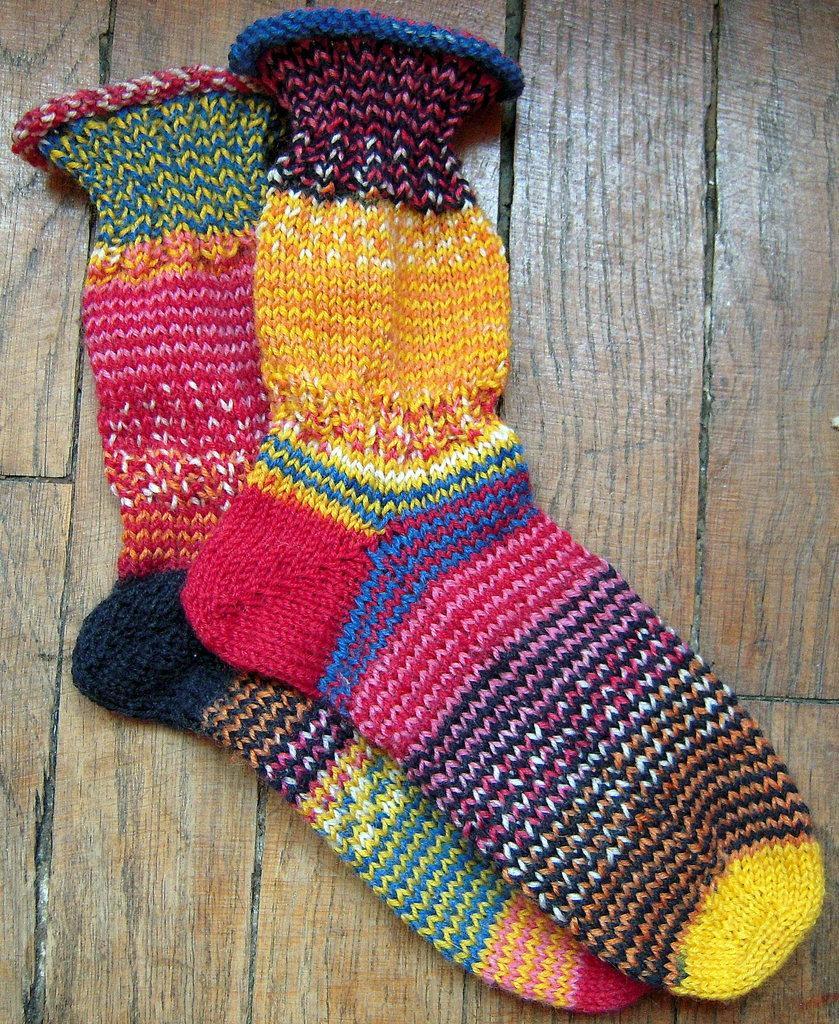Please provide a concise description of this image. In this picture we can see the socks are present on the wood surface. 